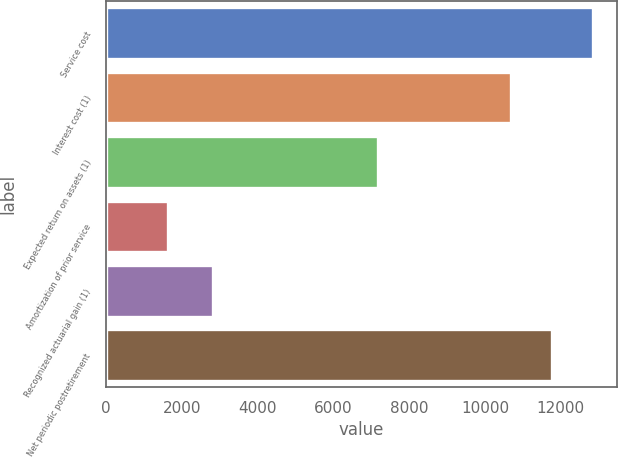<chart> <loc_0><loc_0><loc_500><loc_500><bar_chart><fcel>Service cost<fcel>Interest cost (1)<fcel>Expected return on assets (1)<fcel>Amortization of prior service<fcel>Recognized actuarial gain (1)<fcel>Net periodic postretirement<nl><fcel>12837.4<fcel>10679<fcel>7185<fcel>1644<fcel>2827<fcel>11758.2<nl></chart> 